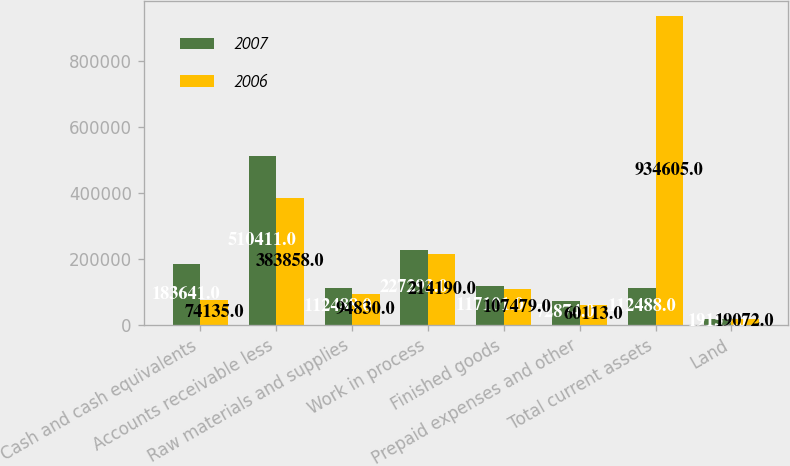Convert chart. <chart><loc_0><loc_0><loc_500><loc_500><stacked_bar_chart><ecel><fcel>Cash and cash equivalents<fcel>Accounts receivable less<fcel>Raw materials and supplies<fcel>Work in process<fcel>Finished goods<fcel>Prepaid expenses and other<fcel>Total current assets<fcel>Land<nl><fcel>2007<fcel>183641<fcel>510411<fcel>112488<fcel>227293<fcel>117101<fcel>72874<fcel>112488<fcel>19159<nl><fcel>2006<fcel>74135<fcel>383858<fcel>94830<fcel>214190<fcel>107479<fcel>60113<fcel>934605<fcel>19072<nl></chart> 